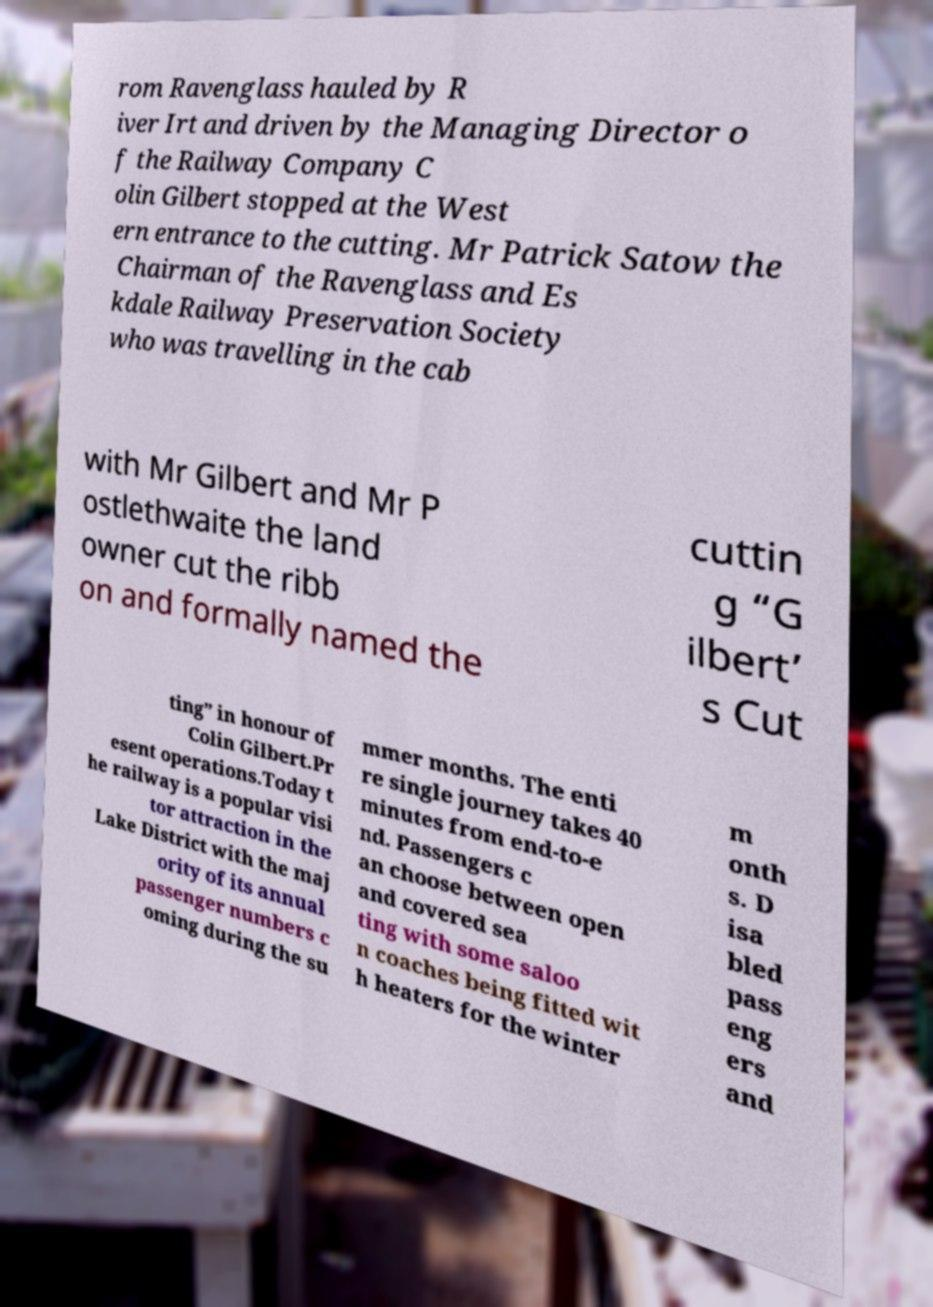What messages or text are displayed in this image? I need them in a readable, typed format. rom Ravenglass hauled by R iver Irt and driven by the Managing Director o f the Railway Company C olin Gilbert stopped at the West ern entrance to the cutting. Mr Patrick Satow the Chairman of the Ravenglass and Es kdale Railway Preservation Society who was travelling in the cab with Mr Gilbert and Mr P ostlethwaite the land owner cut the ribb on and formally named the cuttin g “G ilbert’ s Cut ting” in honour of Colin Gilbert.Pr esent operations.Today t he railway is a popular visi tor attraction in the Lake District with the maj ority of its annual passenger numbers c oming during the su mmer months. The enti re single journey takes 40 minutes from end-to-e nd. Passengers c an choose between open and covered sea ting with some saloo n coaches being fitted wit h heaters for the winter m onth s. D isa bled pass eng ers and 